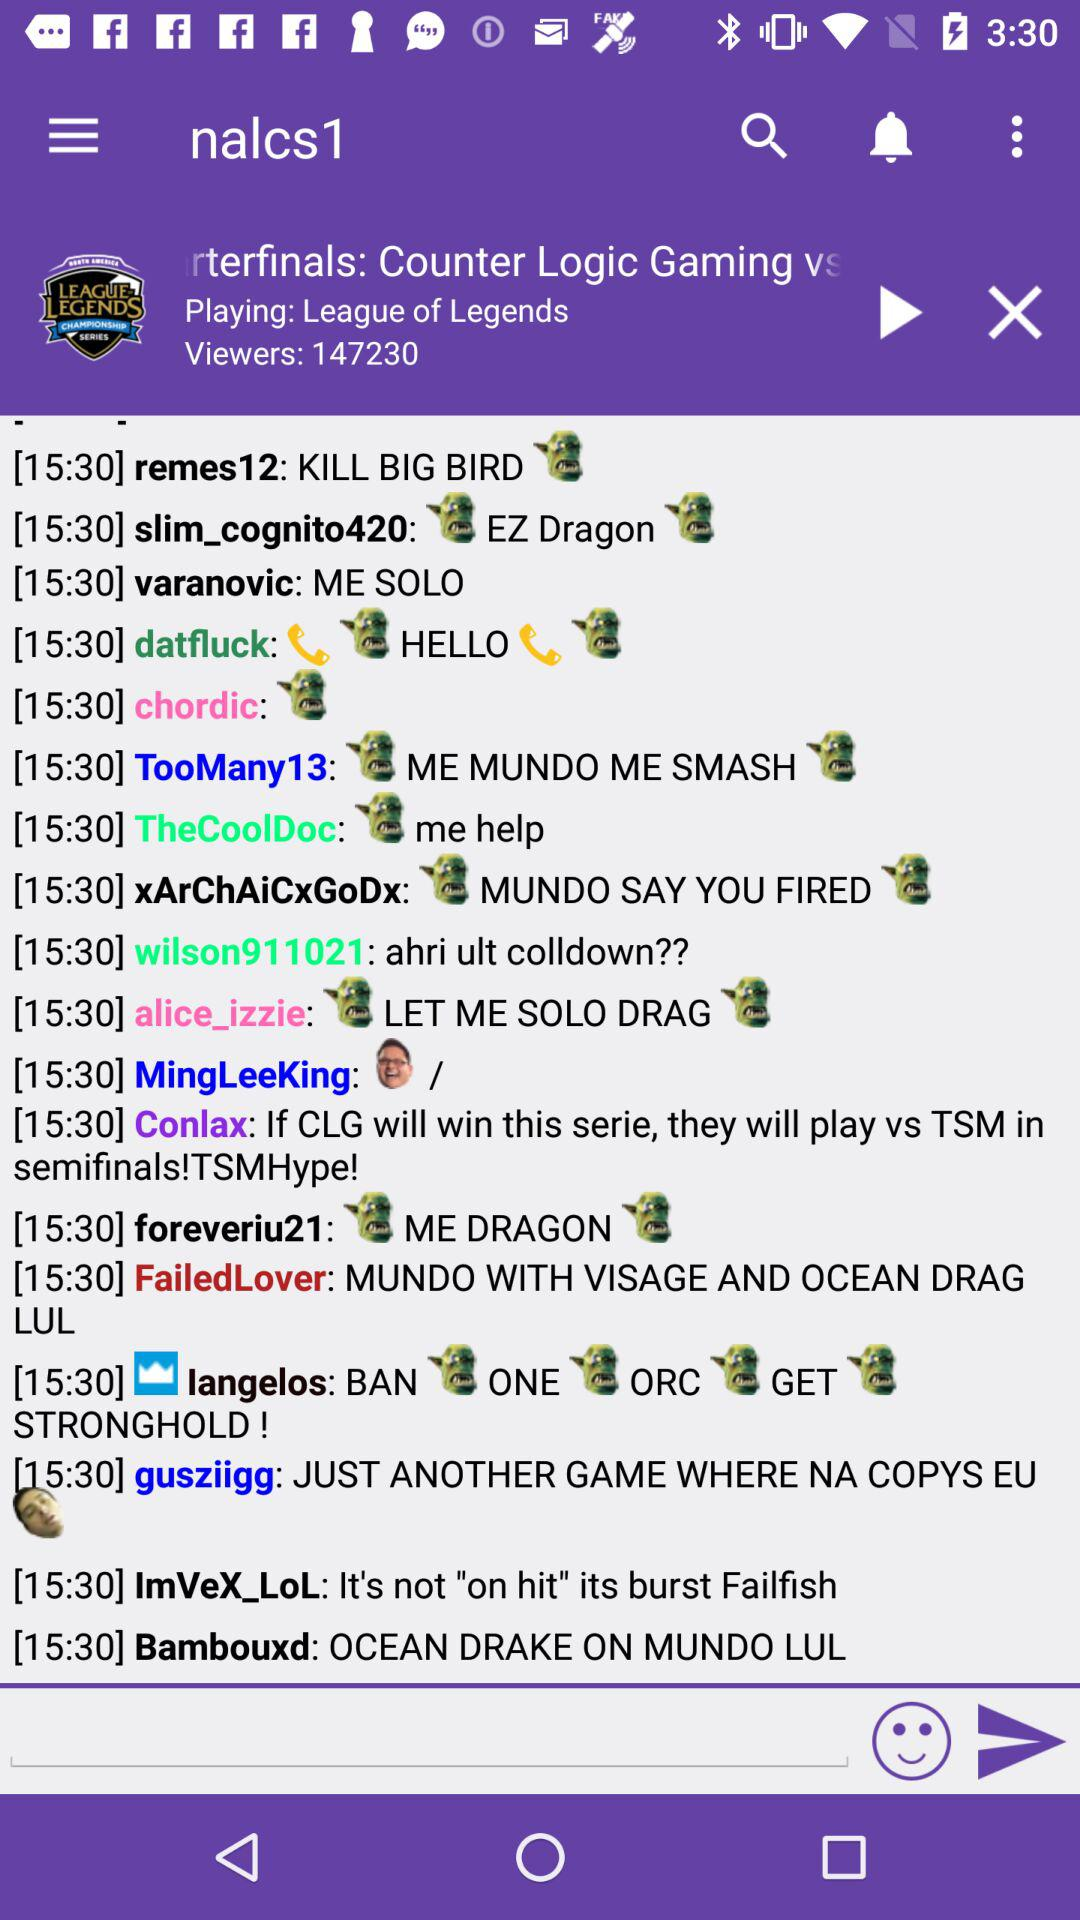How many viewers are there? There are 147230 viewers. 